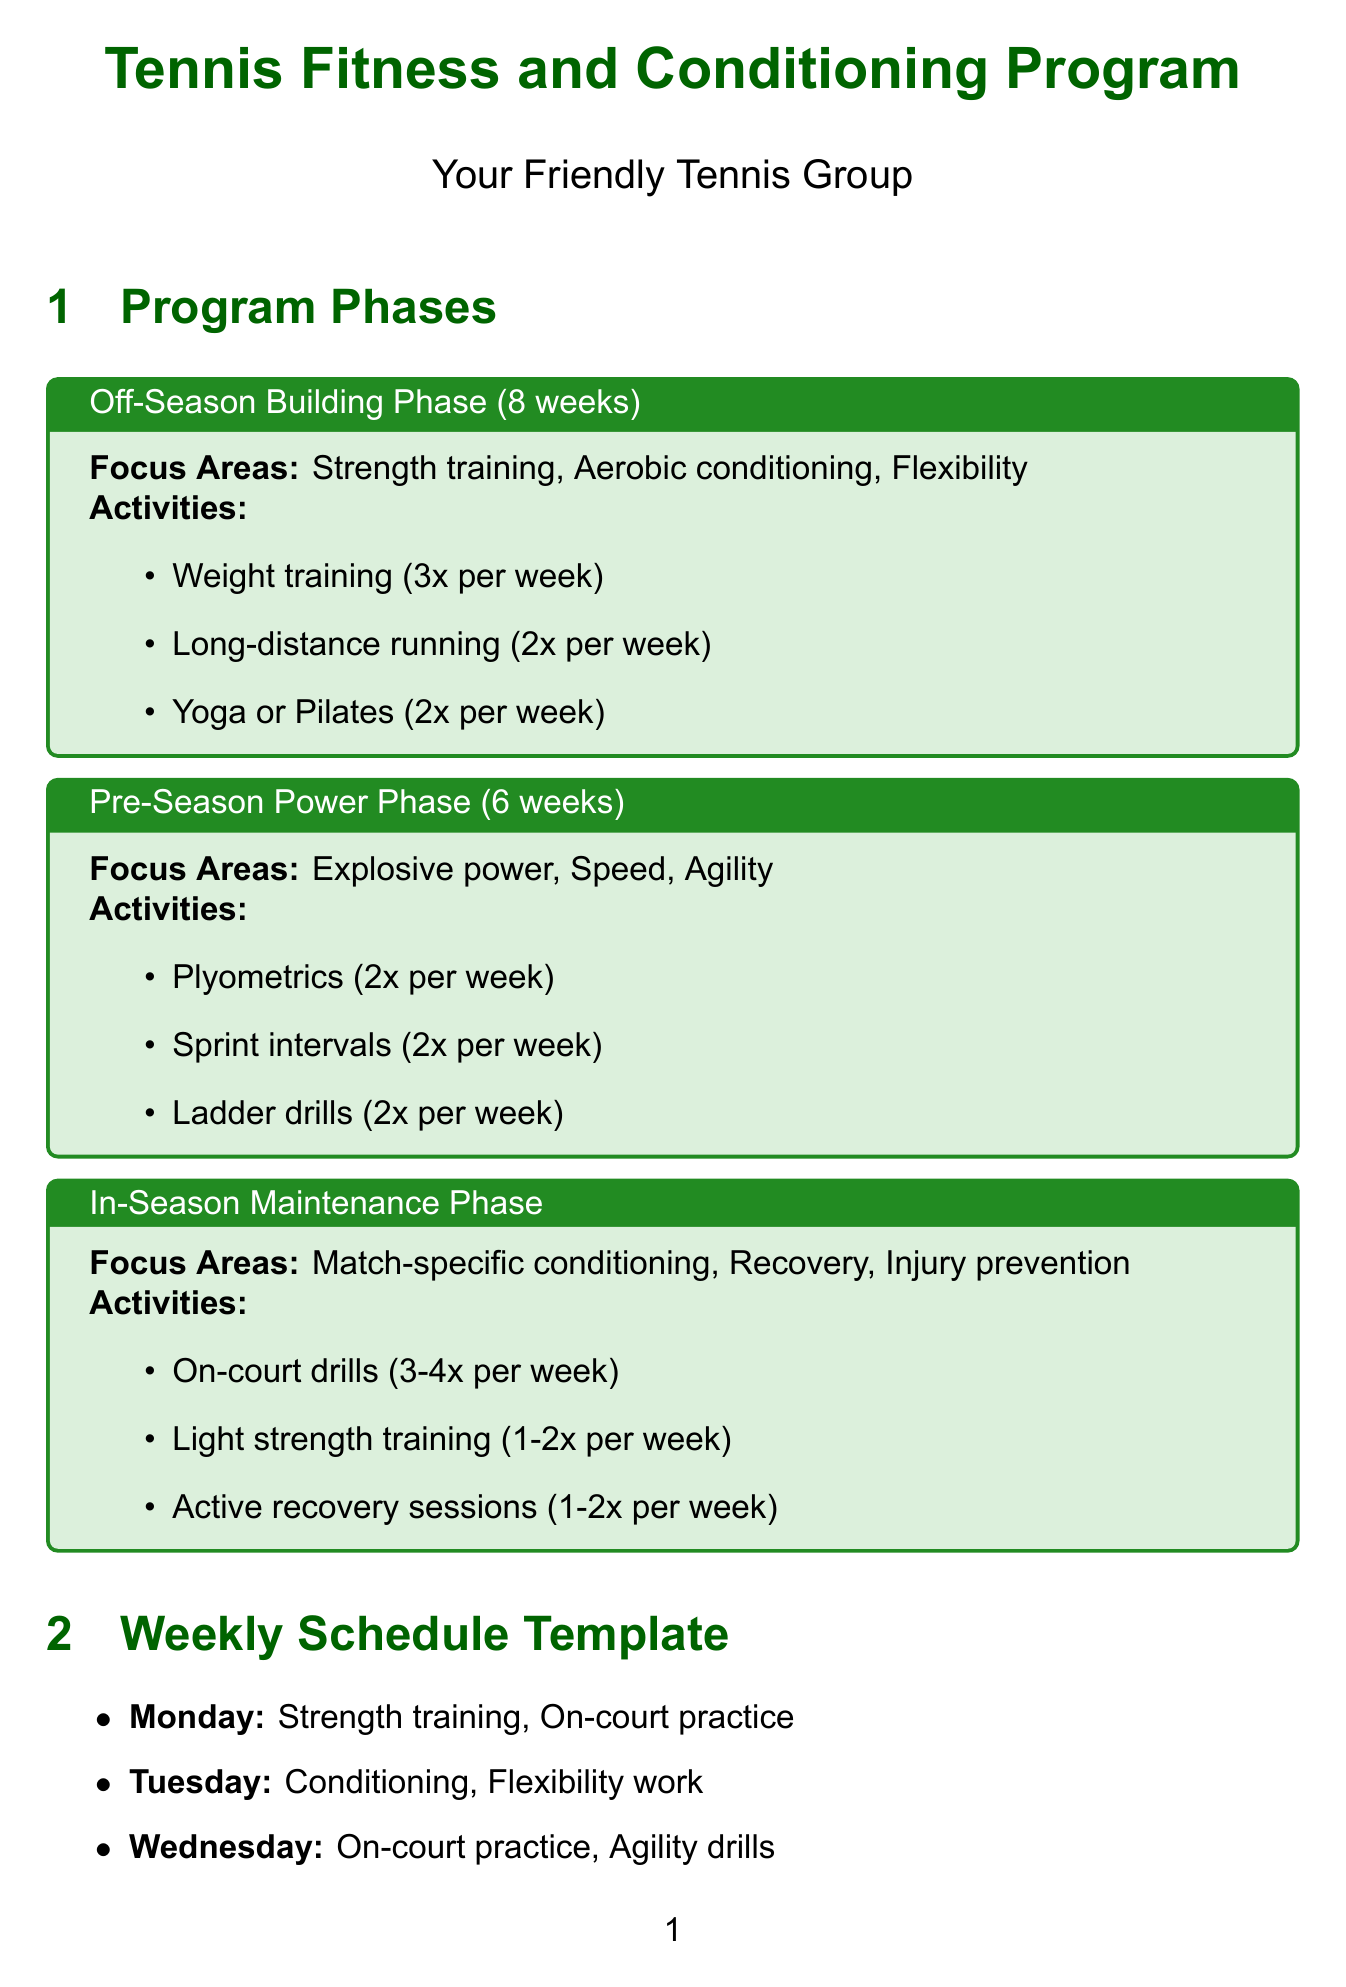What is the duration of the Off-Season Building Phase? The duration is specified in the document, which states it lasts for 8 weeks.
Answer: 8 weeks How many times per week is weight training performed? The document lists the frequency of weight training activities as 3 times per week.
Answer: 3x per week What is one activity included in the Pre-Season Power Phase? The document identifies specific activities within the Pre-Season Power Phase, mentioning plyometrics as one of them.
Answer: Plyometrics How many nutritional guidelines are mentioned in the document? The document has three main nutritional guidelines outlined under the nutrition section.
Answer: 3 What are two focus areas of the In-Season Maintenance Phase? The document indicates multiple focus areas, including match-specific conditioning and injury prevention among others.
Answer: Match-specific conditioning, Injury prevention What is the frequency of fitness tests mentioned in the Progress Tracking section? The document states that fitness tests are conducted every 4 weeks.
Answer: Every 4 weeks Which equipment is recommended for the fitness program? The document lists several pieces of equipment needed, including resistance bands.
Answer: Resistance bands How many weeks does the Pre-Season Power Phase last? The document clearly states the duration of the Pre-Season Power Phase as being 6 weeks.
Answer: 6 weeks 